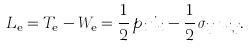Convert formula to latex. <formula><loc_0><loc_0><loc_500><loc_500>\L L _ { \text {e} } = T _ { \text {e} } - W _ { \text {e} } = \frac { 1 } { 2 } \, p _ { i } \, \dot { u } _ { i } - \frac { 1 } { 2 } \, \sigma _ { i j } \, u _ { i , j } .</formula> 